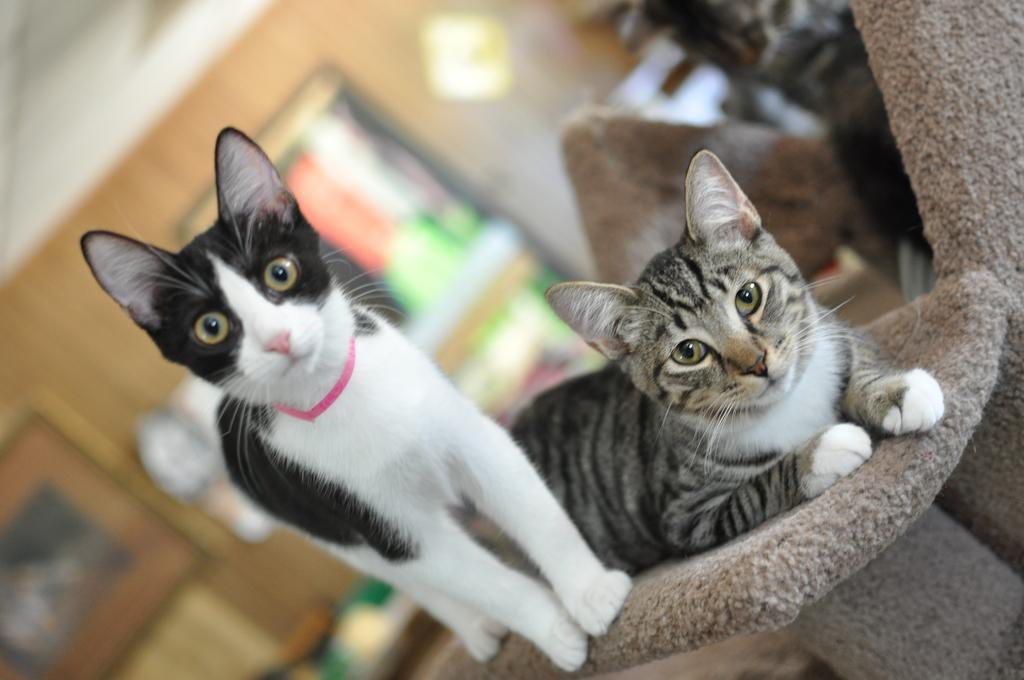How many cats are in the image? There are two cats in the image. What are the cats doing in the image? The cats are on an object. What can be seen in the background of the image? There are objects visible in the background of the image. How would you describe the background in the image? The background is blurry. Is there any snow visible in the image? There is no snow present in the image. What type of party is happening in the image? There is no party depicted in the image. 